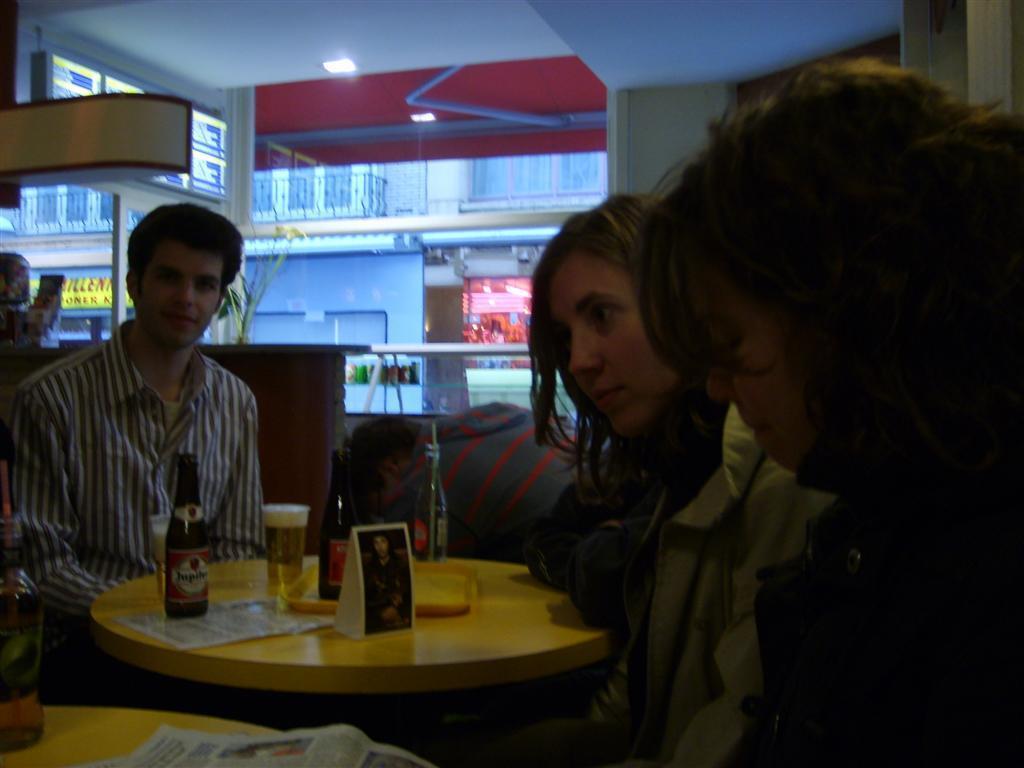Can you describe this image briefly? This is a picture where group of people sitting in the chairs near the table and in table there are glass, bottle, a photo and in back ground there is a building and a light. 